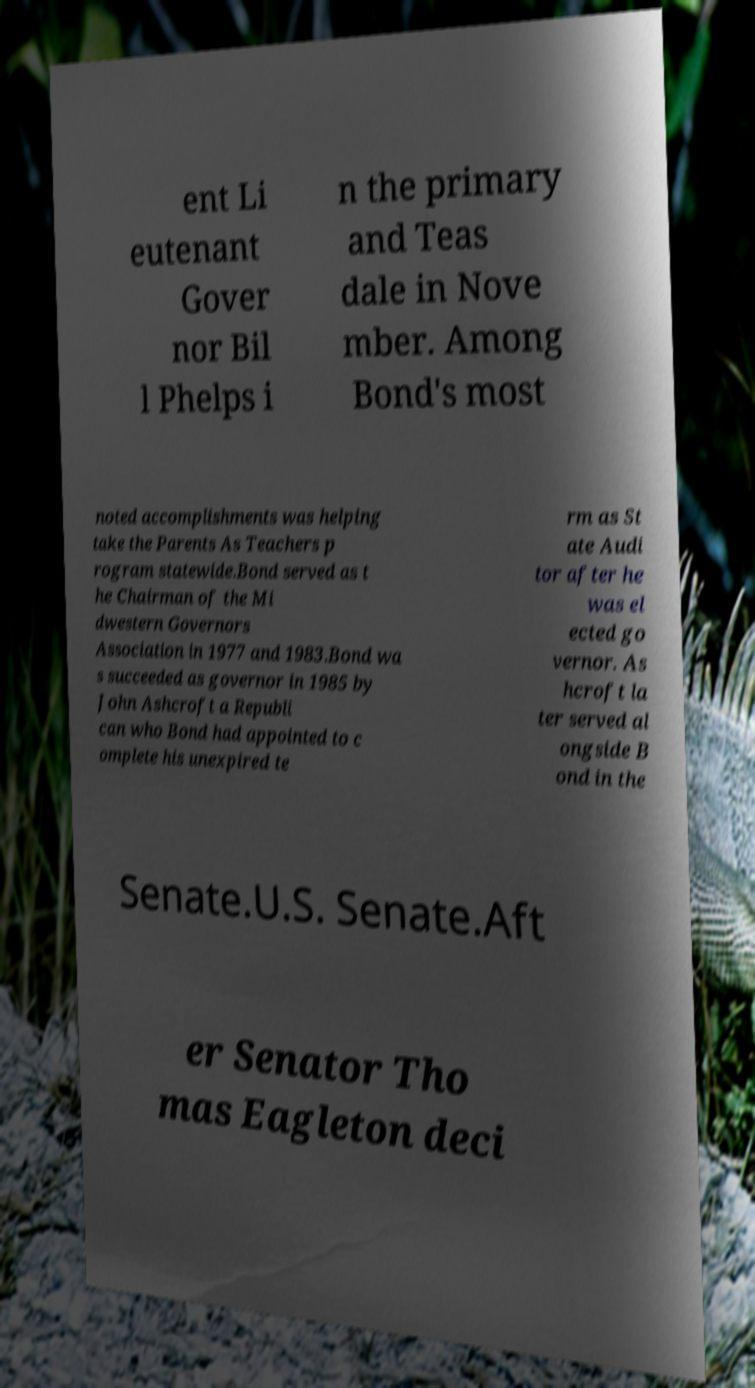Could you assist in decoding the text presented in this image and type it out clearly? ent Li eutenant Gover nor Bil l Phelps i n the primary and Teas dale in Nove mber. Among Bond's most noted accomplishments was helping take the Parents As Teachers p rogram statewide.Bond served as t he Chairman of the Mi dwestern Governors Association in 1977 and 1983.Bond wa s succeeded as governor in 1985 by John Ashcroft a Republi can who Bond had appointed to c omplete his unexpired te rm as St ate Audi tor after he was el ected go vernor. As hcroft la ter served al ongside B ond in the Senate.U.S. Senate.Aft er Senator Tho mas Eagleton deci 